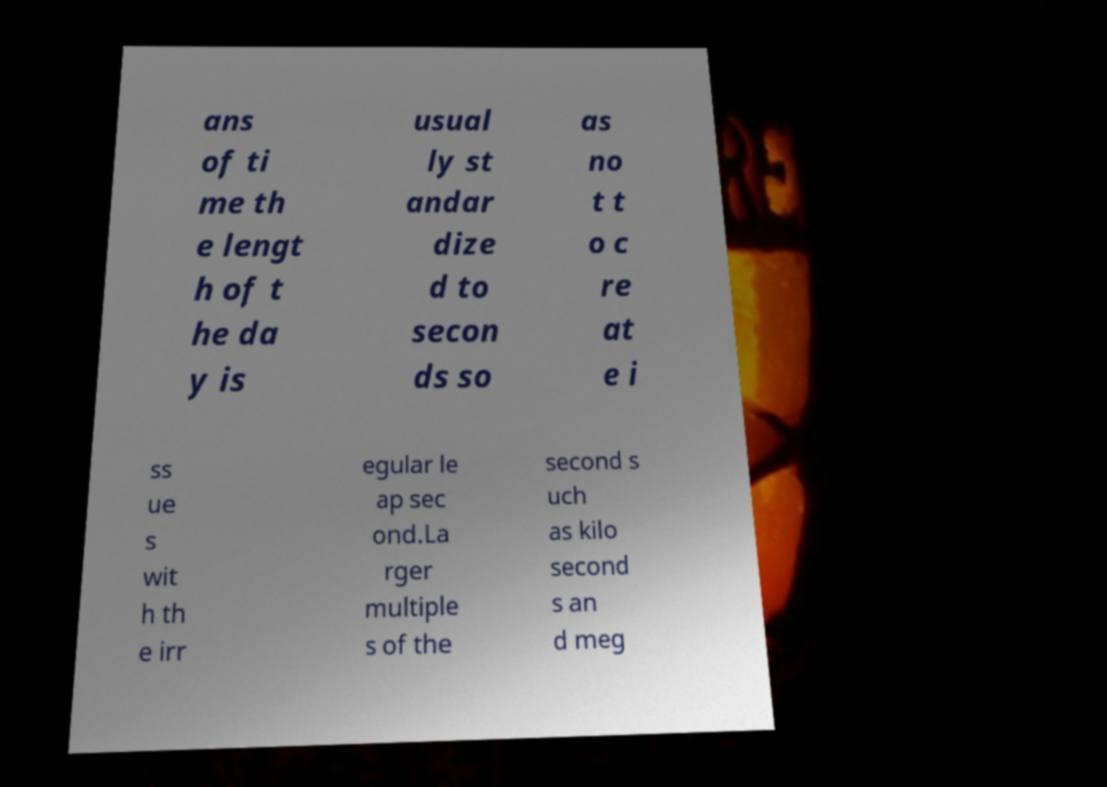Please identify and transcribe the text found in this image. ans of ti me th e lengt h of t he da y is usual ly st andar dize d to secon ds so as no t t o c re at e i ss ue s wit h th e irr egular le ap sec ond.La rger multiple s of the second s uch as kilo second s an d meg 